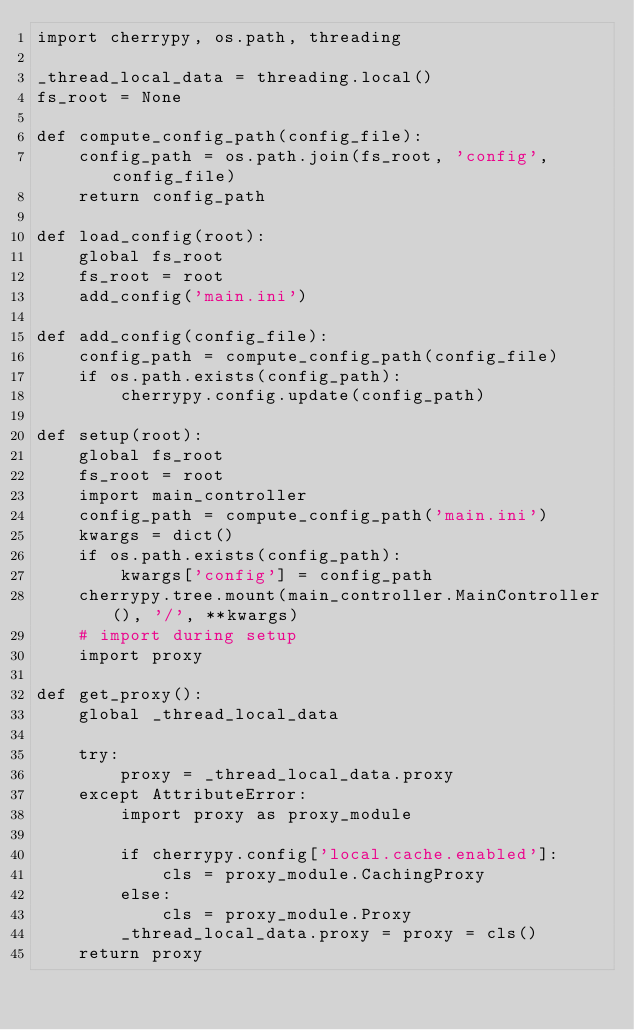Convert code to text. <code><loc_0><loc_0><loc_500><loc_500><_Python_>import cherrypy, os.path, threading

_thread_local_data = threading.local()
fs_root = None

def compute_config_path(config_file):
    config_path = os.path.join(fs_root, 'config', config_file)
    return config_path

def load_config(root):
    global fs_root
    fs_root = root
    add_config('main.ini')

def add_config(config_file):
    config_path = compute_config_path(config_file)
    if os.path.exists(config_path):
        cherrypy.config.update(config_path)

def setup(root):
    global fs_root
    fs_root = root
    import main_controller
    config_path = compute_config_path('main.ini')
    kwargs = dict()
    if os.path.exists(config_path):
        kwargs['config'] = config_path
    cherrypy.tree.mount(main_controller.MainController(), '/', **kwargs)
    # import during setup
    import proxy

def get_proxy():
    global _thread_local_data
    
    try:
        proxy = _thread_local_data.proxy
    except AttributeError:
        import proxy as proxy_module
        
        if cherrypy.config['local.cache.enabled']:
            cls = proxy_module.CachingProxy
        else:
            cls = proxy_module.Proxy
        _thread_local_data.proxy = proxy = cls()
    return proxy
</code> 